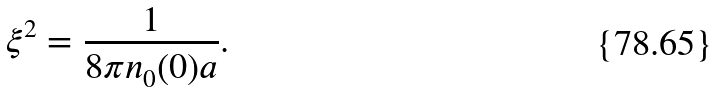Convert formula to latex. <formula><loc_0><loc_0><loc_500><loc_500>\xi ^ { 2 } = \frac { 1 } { 8 \pi n _ { 0 } ( 0 ) a } .</formula> 